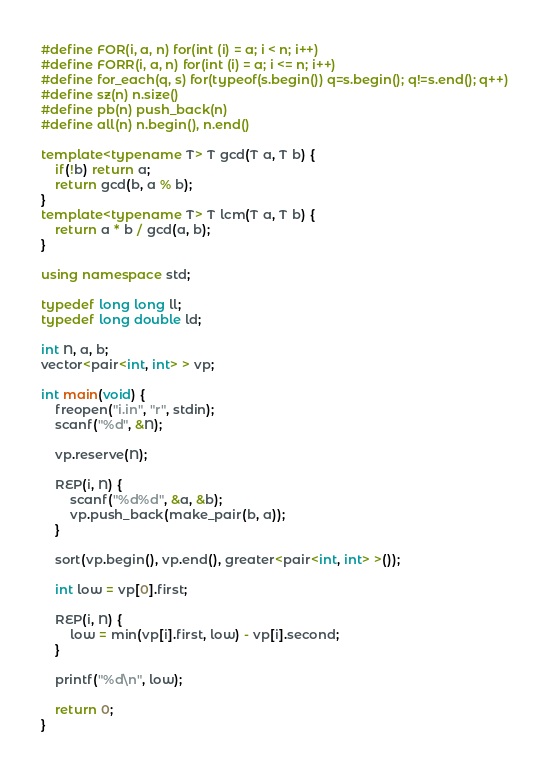<code> <loc_0><loc_0><loc_500><loc_500><_C++_>#define FOR(i, a, n) for(int (i) = a; i < n; i++)
#define FORR(i, a, n) for(int (i) = a; i <= n; i++)
#define for_each(q, s) for(typeof(s.begin()) q=s.begin(); q!=s.end(); q++)
#define sz(n) n.size()
#define pb(n) push_back(n)
#define all(n) n.begin(), n.end()

template<typename T> T gcd(T a, T b) {
    if(!b) return a;
    return gcd(b, a % b);
}
template<typename T> T lcm(T a, T b) {
    return a * b / gcd(a, b);
}

using namespace std;

typedef long long ll;
typedef long double ld;

int N, a, b;
vector<pair<int, int> > vp;

int main(void) {
    freopen("i.in", "r", stdin);
    scanf("%d", &N);

    vp.reserve(N);

    REP(i, N) {
        scanf("%d%d", &a, &b);
        vp.push_back(make_pair(b, a));
    }

    sort(vp.begin(), vp.end(), greater<pair<int, int> >());

    int low = vp[0].first;

    REP(i, N) {
        low = min(vp[i].first, low) - vp[i].second;
    }

    printf("%d\n", low);

    return 0;
}
</code> 